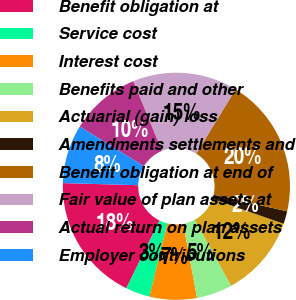Convert chart. <chart><loc_0><loc_0><loc_500><loc_500><pie_chart><fcel>Benefit obligation at<fcel>Service cost<fcel>Interest cost<fcel>Benefits paid and other<fcel>Actuarial (gain) loss<fcel>Amendments settlements and<fcel>Benefit obligation at end of<fcel>Fair value of plan assets at<fcel>Actual return on plan assets<fcel>Employer contributions<nl><fcel>18.18%<fcel>3.45%<fcel>6.73%<fcel>5.09%<fcel>11.64%<fcel>1.82%<fcel>19.82%<fcel>14.91%<fcel>10.0%<fcel>8.36%<nl></chart> 